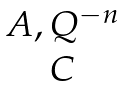<formula> <loc_0><loc_0><loc_500><loc_500>\begin{matrix} A , Q ^ { - n } \\ C \end{matrix}</formula> 